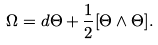<formula> <loc_0><loc_0><loc_500><loc_500>\Omega = d \Theta + \frac { 1 } { 2 } [ \Theta \wedge \Theta ] .</formula> 